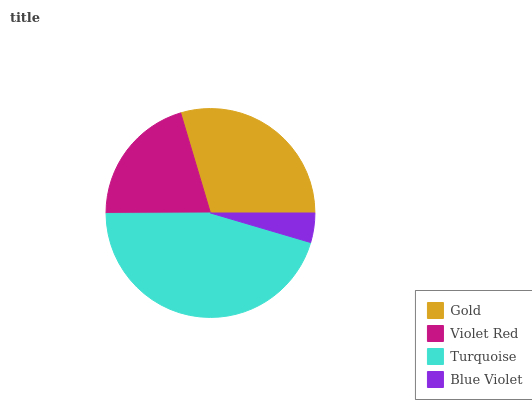Is Blue Violet the minimum?
Answer yes or no. Yes. Is Turquoise the maximum?
Answer yes or no. Yes. Is Violet Red the minimum?
Answer yes or no. No. Is Violet Red the maximum?
Answer yes or no. No. Is Gold greater than Violet Red?
Answer yes or no. Yes. Is Violet Red less than Gold?
Answer yes or no. Yes. Is Violet Red greater than Gold?
Answer yes or no. No. Is Gold less than Violet Red?
Answer yes or no. No. Is Gold the high median?
Answer yes or no. Yes. Is Violet Red the low median?
Answer yes or no. Yes. Is Violet Red the high median?
Answer yes or no. No. Is Turquoise the low median?
Answer yes or no. No. 